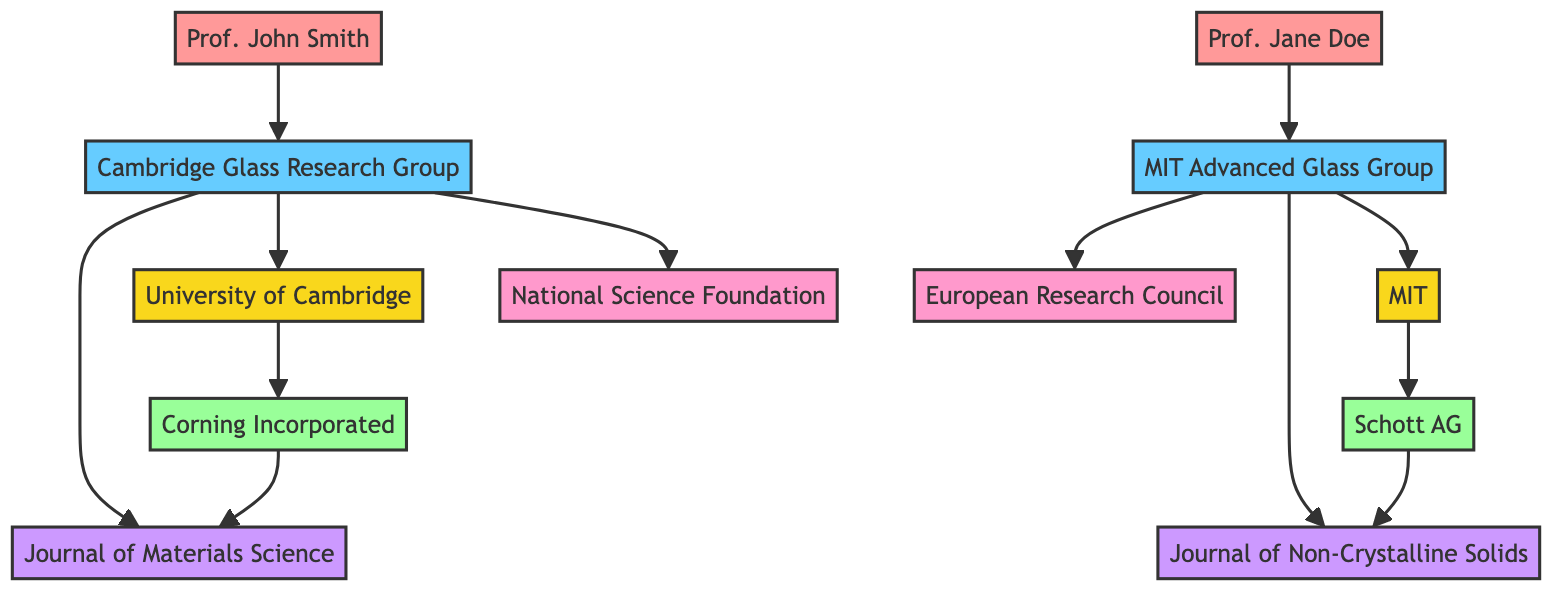What is the total number of nodes in the diagram? There are 12 nodes represented in the diagram: 2 universities, 2 researchers, 2 research groups, 2 industries, 2 funding agencies, and 2 journals. Adding these up gives a total of 12 nodes.
Answer: 12 Which university is associated with the Cambridge Glass Research Group? The Cambridge Glass Research Group is affiliated with the University of Cambridge, as indicated by their connection in the edges of the diagram.
Answer: University of Cambridge How many funding agencies are linked to the research groups? There are 2 funding agencies linked to the research groups: the National Science Foundation linked to the Cambridge Glass Research Group and the European Research Council linked to the MIT Advanced Glass Group.
Answer: 2 What relationship exists between University of Cambridge and Corning Incorporated? The relationship between University of Cambridge and Corning Incorporated is a direct link, indicating some form of collaboration or partnership between the two entities.
Answer: Collaboration Which journal is associated with the MIT Advanced Glass Group? The MIT Advanced Glass Group is associated with the Journal of Non-Crystalline Solids, as shown by the directed edge linking them in the diagram.
Answer: Journal of Non-Crystalline Solids Which researcher is affiliated with MIT? The researcher affiliated with MIT is Prof. Jane Doe, clearly indicated in the nodes and identified as part of the MIT Advanced Glass Group.
Answer: Prof. Jane Doe What type of nodes are connected to the Journal of Materials Science? The Journal of Materials Science is connected to two types of nodes: the Cambridge Glass Research Group and Corning Incorporated, indicating the contributions of both the research group and the industry towards this journal.
Answer: Research Group and Industry Which node has the most edges connected to it? The Cambridge Glass Research Group has 4 edges connected to it, linking it to a researcher, its university, a funding agency, and a journal, making it the most connected node in the diagram.
Answer: Cambridge Glass Research Group 